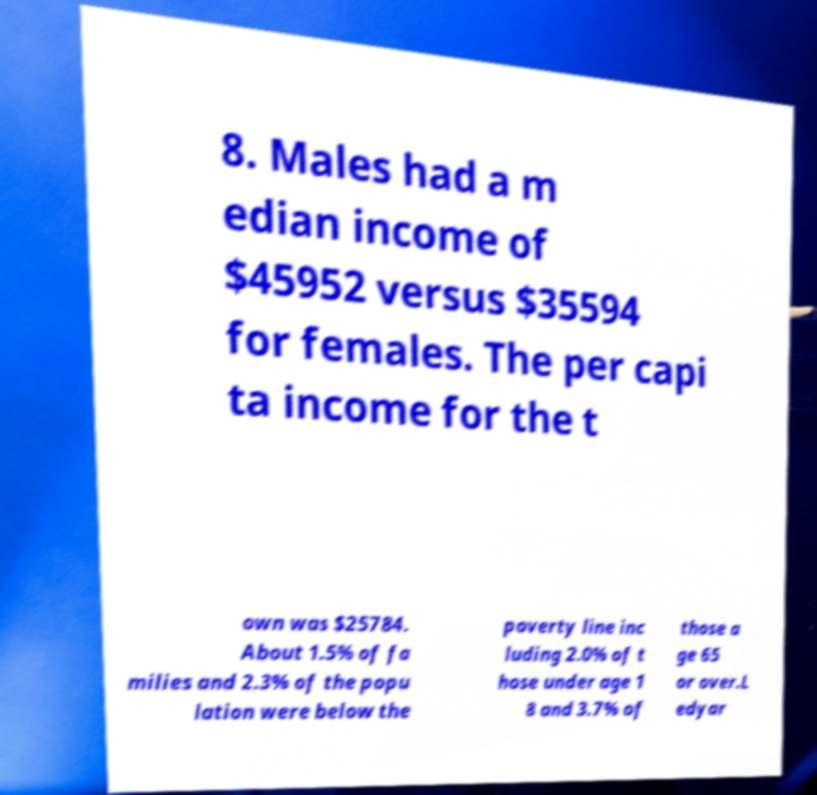Please read and relay the text visible in this image. What does it say? 8. Males had a m edian income of $45952 versus $35594 for females. The per capi ta income for the t own was $25784. About 1.5% of fa milies and 2.3% of the popu lation were below the poverty line inc luding 2.0% of t hose under age 1 8 and 3.7% of those a ge 65 or over.L edyar 